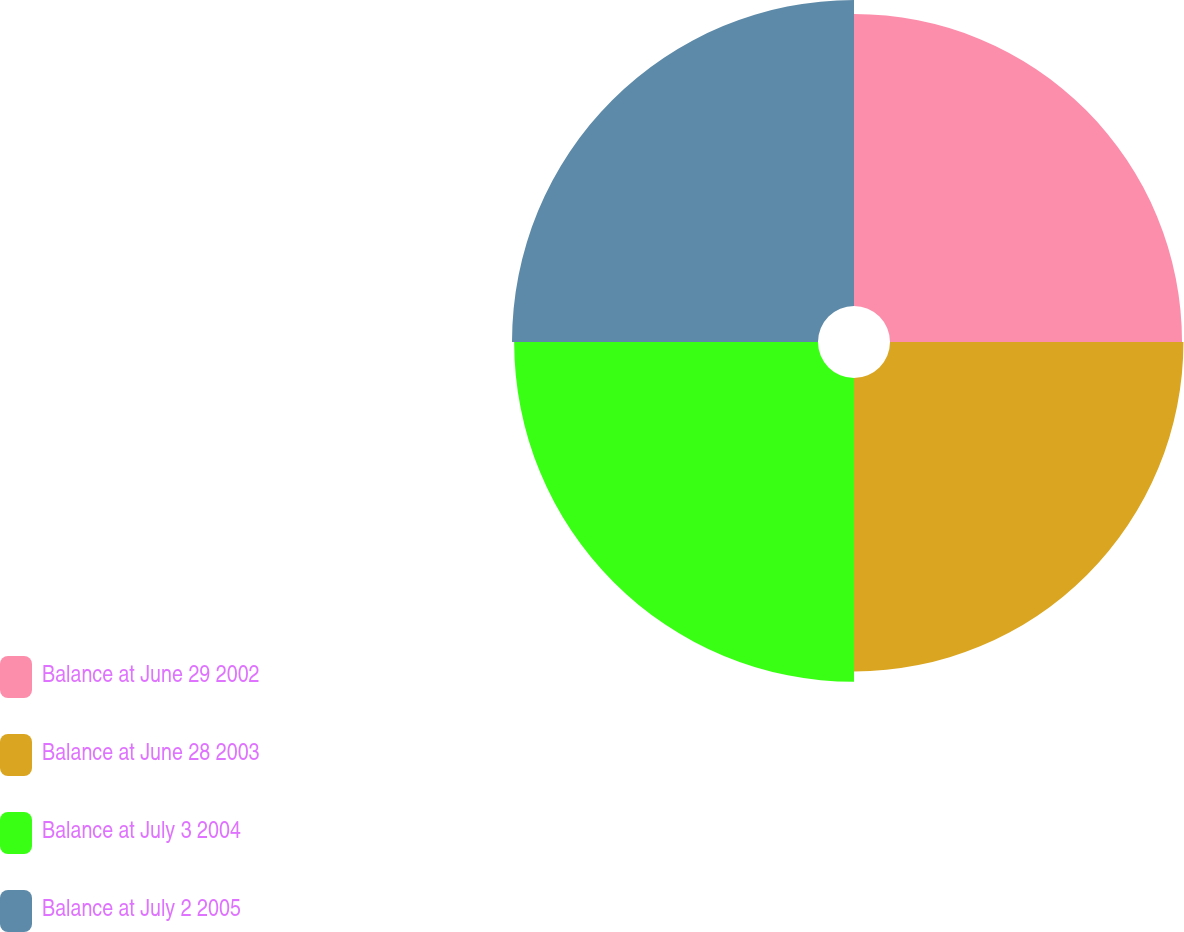Convert chart to OTSL. <chart><loc_0><loc_0><loc_500><loc_500><pie_chart><fcel>Balance at June 29 2002<fcel>Balance at June 28 2003<fcel>Balance at July 3 2004<fcel>Balance at July 2 2005<nl><fcel>24.43%<fcel>24.55%<fcel>25.42%<fcel>25.6%<nl></chart> 